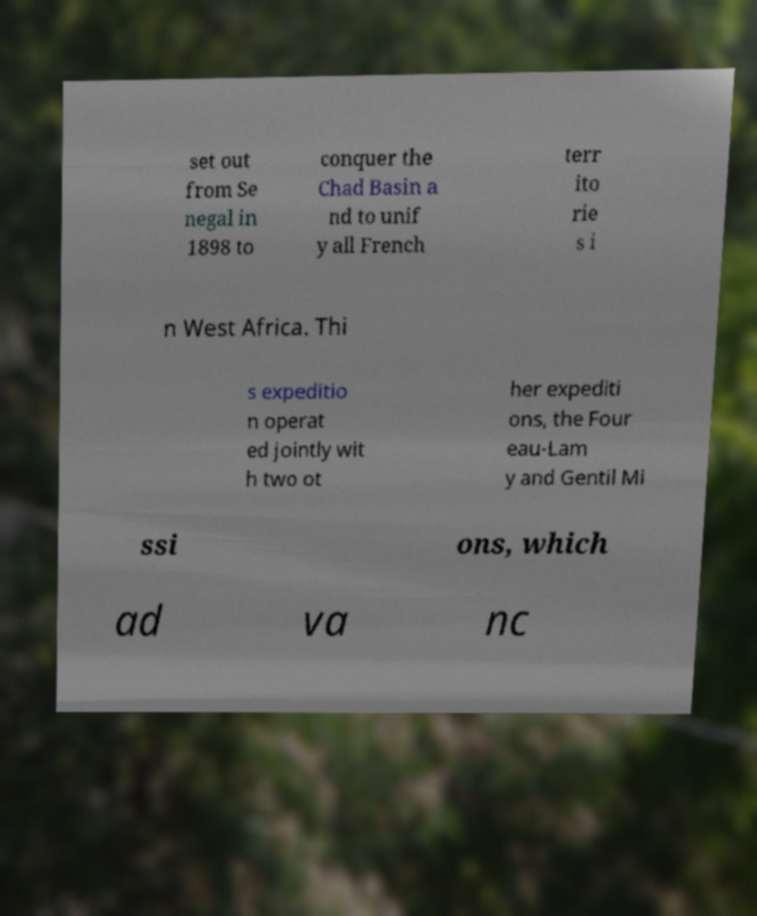Could you extract and type out the text from this image? set out from Se negal in 1898 to conquer the Chad Basin a nd to unif y all French terr ito rie s i n West Africa. Thi s expeditio n operat ed jointly wit h two ot her expediti ons, the Four eau-Lam y and Gentil Mi ssi ons, which ad va nc 